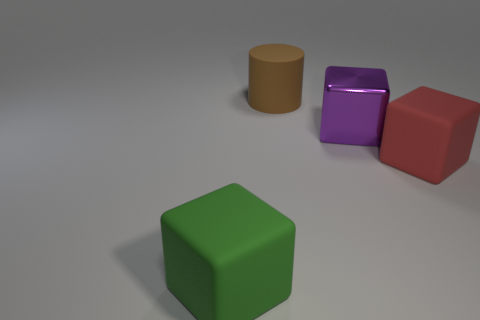Subtract all matte blocks. How many blocks are left? 1 Subtract 0 purple balls. How many objects are left? 4 Subtract all blocks. How many objects are left? 1 Subtract all cyan cylinders. Subtract all yellow cubes. How many cylinders are left? 1 Subtract all red cylinders. How many green blocks are left? 1 Subtract all green balls. Subtract all big brown cylinders. How many objects are left? 3 Add 2 big matte cubes. How many big matte cubes are left? 4 Add 1 big green metallic cubes. How many big green metallic cubes exist? 1 Add 1 green rubber blocks. How many objects exist? 5 